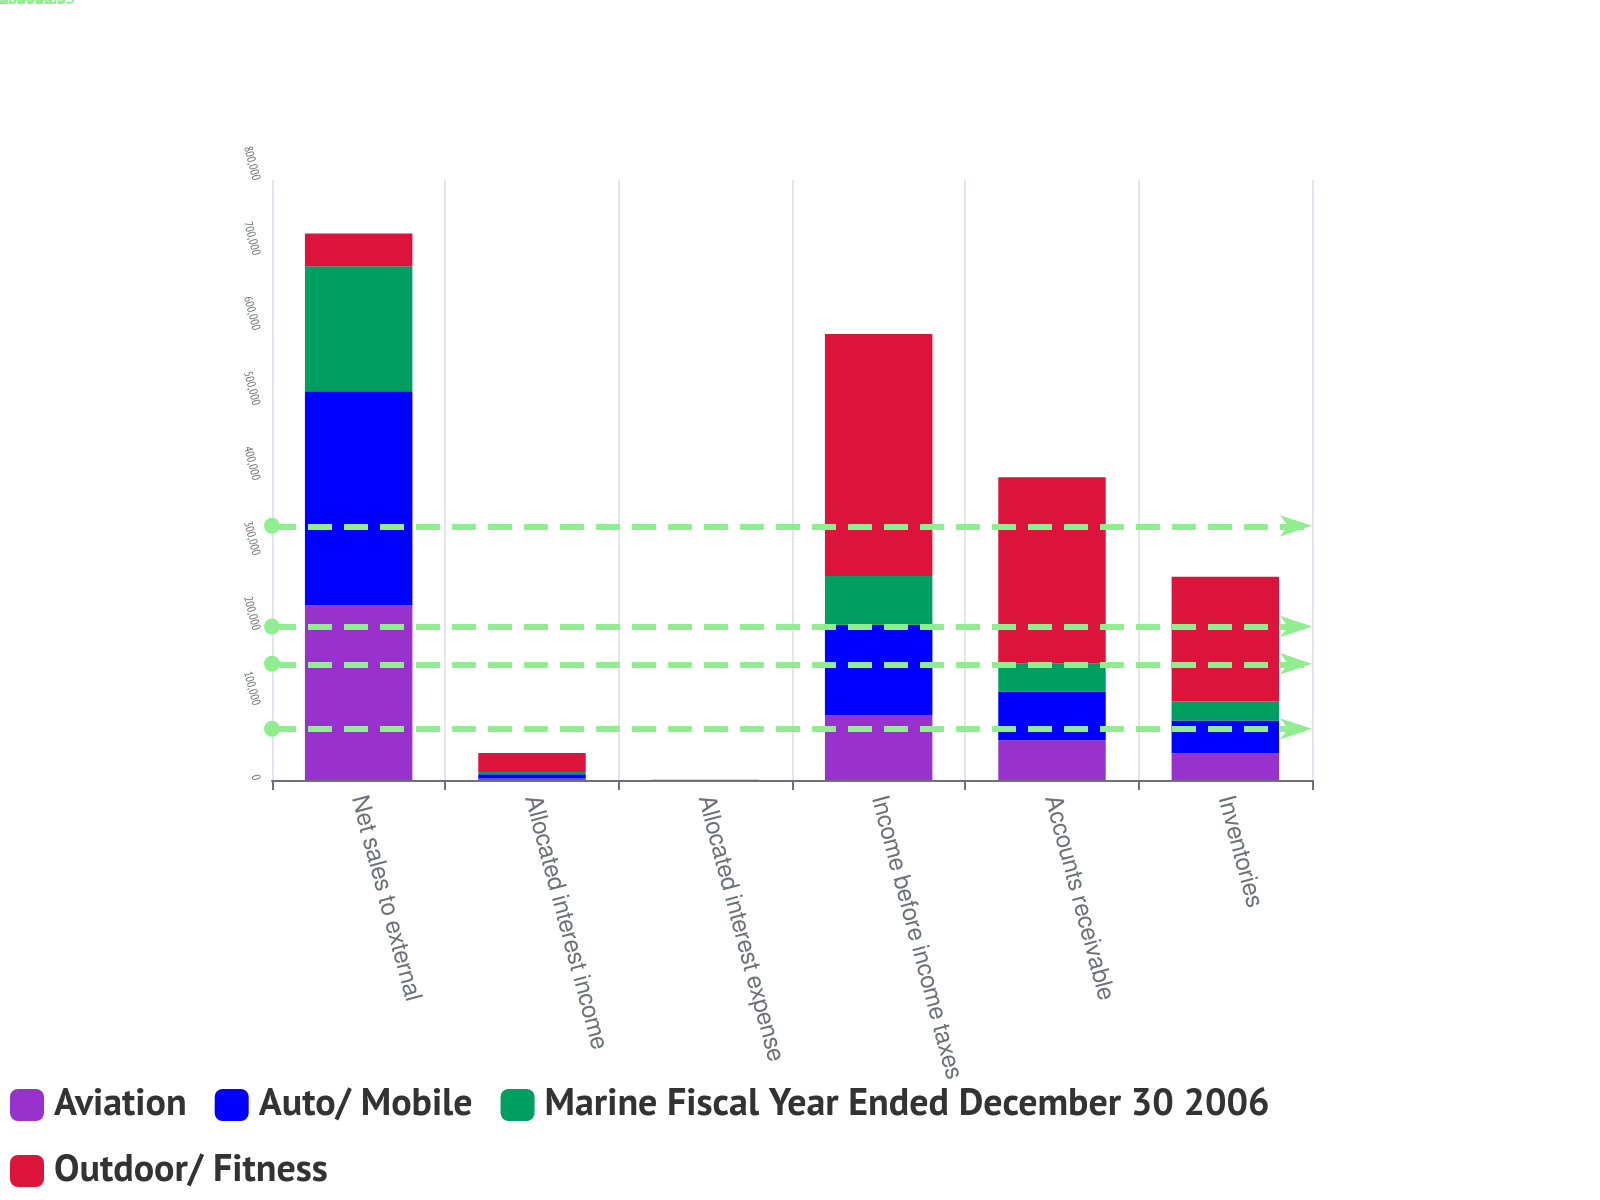Convert chart. <chart><loc_0><loc_0><loc_500><loc_500><stacked_bar_chart><ecel><fcel>Net sales to external<fcel>Allocated interest income<fcel>Allocated interest expense<fcel>Income before income taxes<fcel>Accounts receivable<fcel>Inventories<nl><fcel>Aviation<fcel>232906<fcel>1952<fcel>49<fcel>86141<fcel>52978<fcel>35580<nl><fcel>Auto/ Mobile<fcel>285362<fcel>5693<fcel>44<fcel>120905<fcel>64910<fcel>43594<nl><fcel>Marine Fiscal Year Ended December 30 2006<fcel>166639<fcel>3020<fcel>17<fcel>65087<fcel>37905<fcel>25457<nl><fcel>Outdoor/ Fitness<fcel>43594<fcel>25232<fcel>63<fcel>322421<fcel>247731<fcel>166377<nl></chart> 